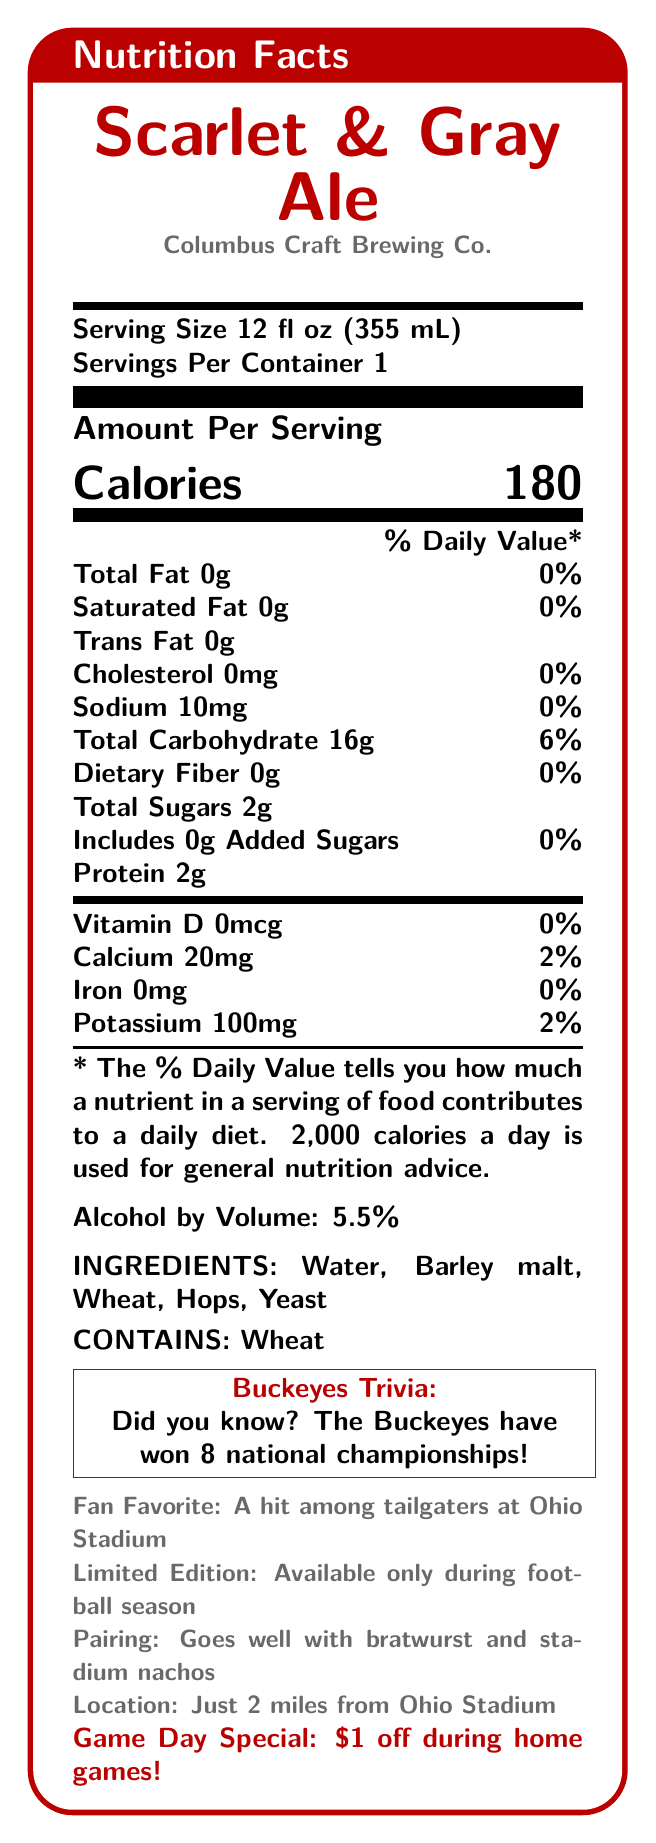what is the serving size of Scarlet & Gray Ale? The serving size is provided under the "Serving Size" section of the label.
Answer: 12 fl oz (355 mL) how many calories are in one serving of Scarlet & Gray Ale? The calorie count is highlighted as part of the "Amount Per Serving" section.
Answer: 180 what is the sodium content per serving? The sodium content is listed under the "Sodium" section.
Answer: 10mg what is the total carbohydrate content per serving? The total carbohydrate content is found under the "Total Carbohydrate" section.
Answer: 16g does Scarlet & Gray Ale contain any dietary fiber? The dietary fiber content is 0g as indicated under the "Dietary Fiber" section.
Answer: No how much protein does each serving contain? The protein content is provided under the "Protein" section.
Answer: 2g how much alcohol by volume does Scarlet & Gray Ale have? The alcohol by volume information is listed under the "Alcohol by Volume" section.
Answer: 5.5% which of the following ingredients is not listed for Scarlet & Gray Ale?
A. Water
B. Hops
C. Rice The ingredients listed are "Water," "Barley malt," "Wheat," "Hops," and "Yeast."
Answer: C how much potassium is in a serving of Scarlet & Gray Ale?
A. 20mg
B. 100mg
C. 50mg
D. 10mg The potassium content is 100mg as indicated in the document.
Answer: B is Scarlet & Gray Ale suitable for someone with a wheat allergy? The allergen information states "Contains: Wheat."
Answer: No is Scarlet & Gray Ale available year-round? The label states "Limited Edition: Available only during football season."
Answer: No what percentage of daily value is the total fat content in Scarlet & Gray Ale? The document states "Total Fat 0g 0%".
Answer: 0% summarize the nutrition facts label for Scarlet & Gray Ale. The nutrition label highlights key nutritional information, serving size, ingredient details, and additional trivia about the product, summarizing all its key attributes and usage suggestions.
Answer: The Scarlet & Gray Ale, brewed by Columbus Craft Brewing Co., features a serving size of 12 fl oz with 180 calories. It contains 0g total fat, 10mg sodium, 16g total carbohydrates (including 2g total sugars and 0g dietary fiber), and 2g protein per serving. The ale is 5.5% alcohol by volume and ingredients include water, barley malt, wheat, hops, and yeast. It contains wheat and is a limited edition available during football season, popular among Ohio Stadium tailgaters, and pairs well with bratwurst and stadium nachos. what are the detailed steps of the brewing process for Scarlet & Gray Ale? The document does not provide any information regarding the brewing process of Scarlet & Gray Ale; it only lists the nutritional facts and some other product details.
Answer: Cannot be determined 